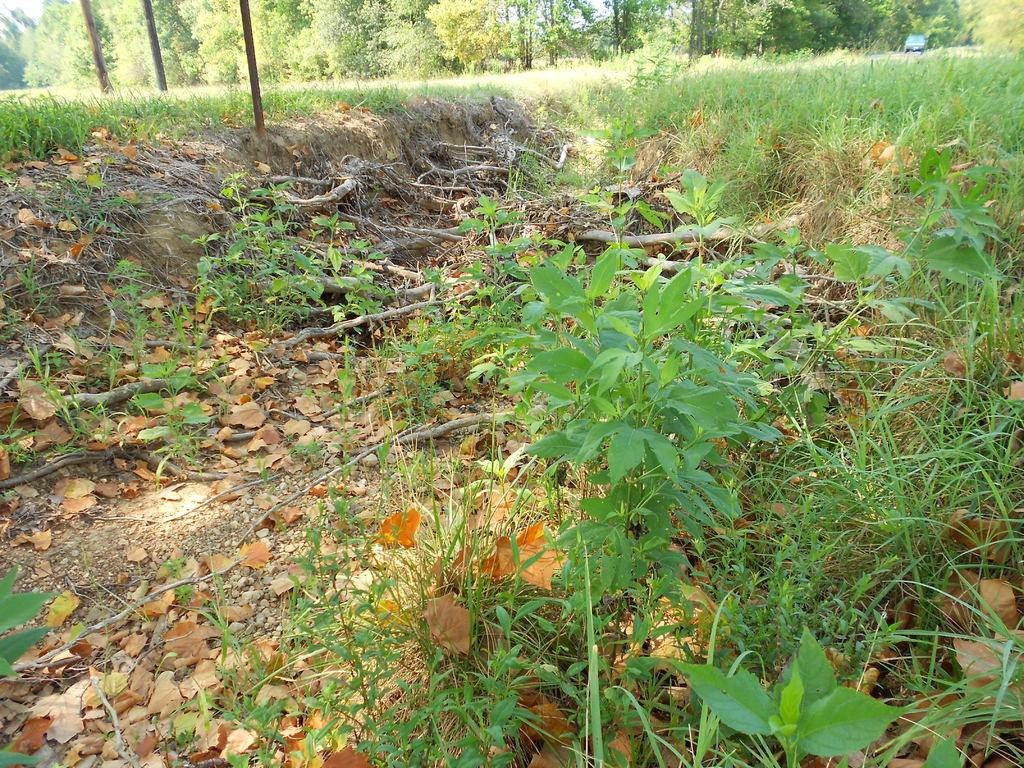What type of vegetation can be seen on the land in the image? There is grass on a land in the image. What can be seen in the background of the image? There are trees in the background of the image. What is the mass of the turkey that is not present in the image? There is no turkey present in the image, so it is not possible to determine its mass. 